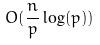<formula> <loc_0><loc_0><loc_500><loc_500>O ( \frac { n } { p } \log ( p ) )</formula> 